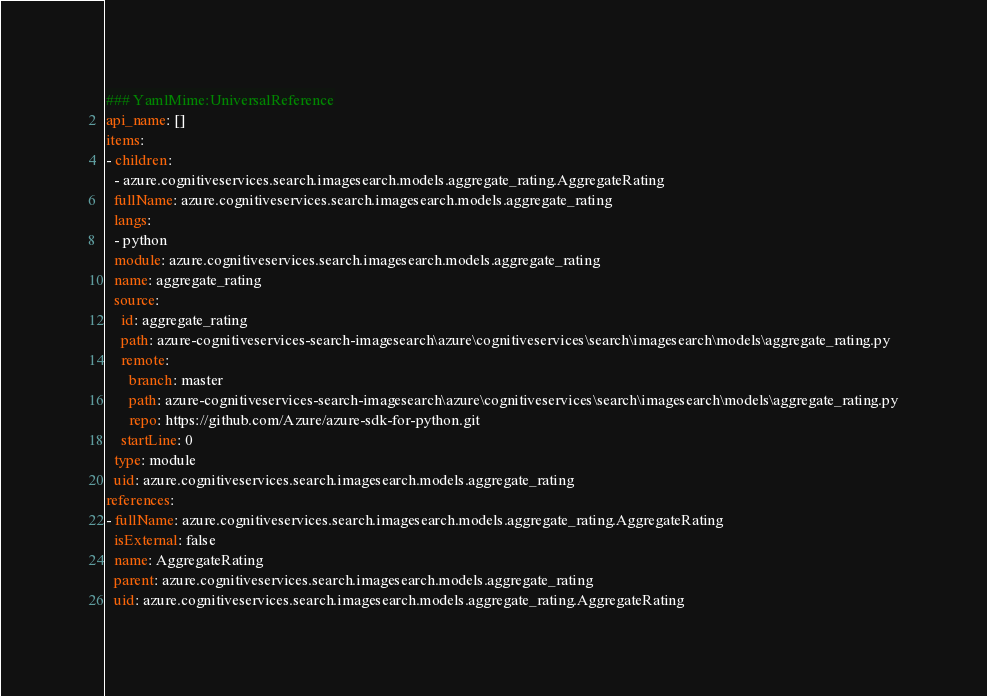Convert code to text. <code><loc_0><loc_0><loc_500><loc_500><_YAML_>### YamlMime:UniversalReference
api_name: []
items:
- children:
  - azure.cognitiveservices.search.imagesearch.models.aggregate_rating.AggregateRating
  fullName: azure.cognitiveservices.search.imagesearch.models.aggregate_rating
  langs:
  - python
  module: azure.cognitiveservices.search.imagesearch.models.aggregate_rating
  name: aggregate_rating
  source:
    id: aggregate_rating
    path: azure-cognitiveservices-search-imagesearch\azure\cognitiveservices\search\imagesearch\models\aggregate_rating.py
    remote:
      branch: master
      path: azure-cognitiveservices-search-imagesearch\azure\cognitiveservices\search\imagesearch\models\aggregate_rating.py
      repo: https://github.com/Azure/azure-sdk-for-python.git
    startLine: 0
  type: module
  uid: azure.cognitiveservices.search.imagesearch.models.aggregate_rating
references:
- fullName: azure.cognitiveservices.search.imagesearch.models.aggregate_rating.AggregateRating
  isExternal: false
  name: AggregateRating
  parent: azure.cognitiveservices.search.imagesearch.models.aggregate_rating
  uid: azure.cognitiveservices.search.imagesearch.models.aggregate_rating.AggregateRating
</code> 